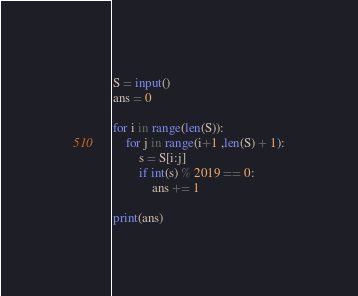Convert code to text. <code><loc_0><loc_0><loc_500><loc_500><_Python_>S = input()
ans = 0

for i in range(len(S)):
    for j in range(i+1 ,len(S) + 1):
        s = S[i:j]
        if int(s) % 2019 == 0:
            ans += 1

print(ans)</code> 